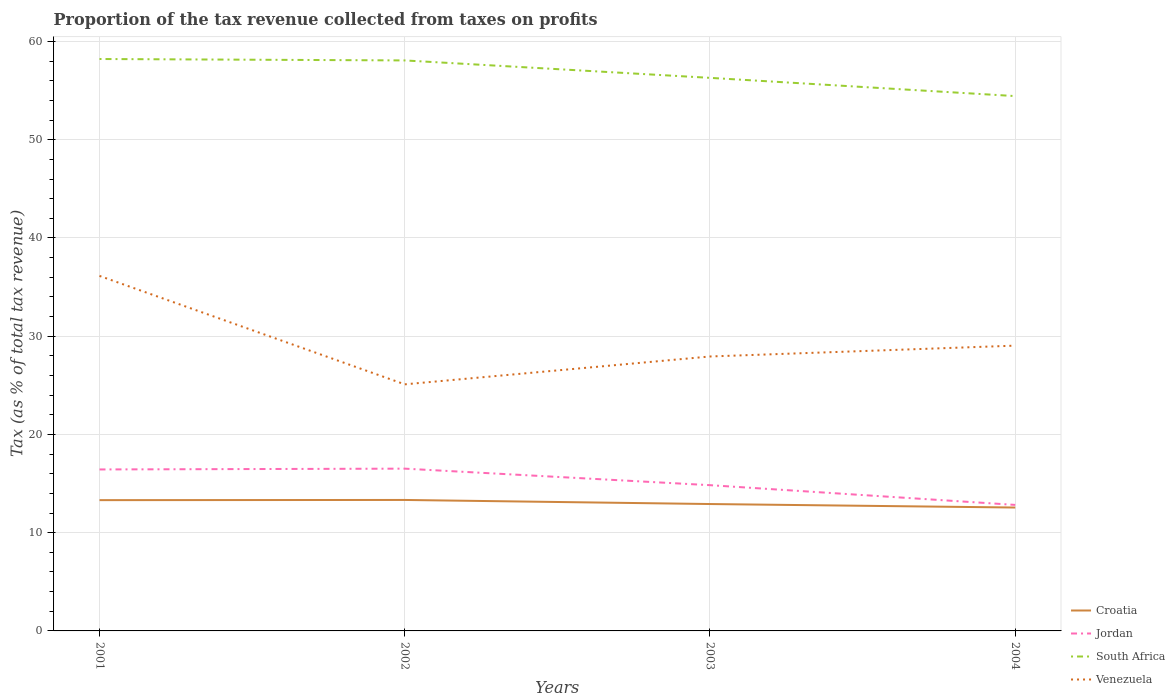How many different coloured lines are there?
Ensure brevity in your answer.  4. Across all years, what is the maximum proportion of the tax revenue collected in Venezuela?
Keep it short and to the point. 25.1. What is the total proportion of the tax revenue collected in Jordan in the graph?
Your response must be concise. -0.08. What is the difference between the highest and the second highest proportion of the tax revenue collected in Croatia?
Provide a succinct answer. 0.77. What is the difference between the highest and the lowest proportion of the tax revenue collected in Croatia?
Make the answer very short. 2. How many lines are there?
Offer a very short reply. 4. What is the difference between two consecutive major ticks on the Y-axis?
Give a very brief answer. 10. Are the values on the major ticks of Y-axis written in scientific E-notation?
Offer a terse response. No. Does the graph contain grids?
Offer a terse response. Yes. Where does the legend appear in the graph?
Your answer should be compact. Bottom right. How many legend labels are there?
Make the answer very short. 4. What is the title of the graph?
Offer a very short reply. Proportion of the tax revenue collected from taxes on profits. Does "Russian Federation" appear as one of the legend labels in the graph?
Keep it short and to the point. No. What is the label or title of the Y-axis?
Provide a short and direct response. Tax (as % of total tax revenue). What is the Tax (as % of total tax revenue) of Croatia in 2001?
Offer a terse response. 13.31. What is the Tax (as % of total tax revenue) in Jordan in 2001?
Keep it short and to the point. 16.44. What is the Tax (as % of total tax revenue) in South Africa in 2001?
Make the answer very short. 58.22. What is the Tax (as % of total tax revenue) in Venezuela in 2001?
Offer a terse response. 36.14. What is the Tax (as % of total tax revenue) of Croatia in 2002?
Offer a terse response. 13.33. What is the Tax (as % of total tax revenue) in Jordan in 2002?
Offer a terse response. 16.52. What is the Tax (as % of total tax revenue) of South Africa in 2002?
Make the answer very short. 58.08. What is the Tax (as % of total tax revenue) of Venezuela in 2002?
Give a very brief answer. 25.1. What is the Tax (as % of total tax revenue) of Croatia in 2003?
Keep it short and to the point. 12.92. What is the Tax (as % of total tax revenue) of Jordan in 2003?
Give a very brief answer. 14.84. What is the Tax (as % of total tax revenue) in South Africa in 2003?
Provide a succinct answer. 56.3. What is the Tax (as % of total tax revenue) in Venezuela in 2003?
Your answer should be very brief. 27.94. What is the Tax (as % of total tax revenue) of Croatia in 2004?
Offer a very short reply. 12.56. What is the Tax (as % of total tax revenue) in Jordan in 2004?
Provide a succinct answer. 12.83. What is the Tax (as % of total tax revenue) in South Africa in 2004?
Give a very brief answer. 54.45. What is the Tax (as % of total tax revenue) of Venezuela in 2004?
Offer a terse response. 29.04. Across all years, what is the maximum Tax (as % of total tax revenue) in Croatia?
Offer a very short reply. 13.33. Across all years, what is the maximum Tax (as % of total tax revenue) in Jordan?
Your response must be concise. 16.52. Across all years, what is the maximum Tax (as % of total tax revenue) in South Africa?
Provide a succinct answer. 58.22. Across all years, what is the maximum Tax (as % of total tax revenue) of Venezuela?
Keep it short and to the point. 36.14. Across all years, what is the minimum Tax (as % of total tax revenue) in Croatia?
Offer a very short reply. 12.56. Across all years, what is the minimum Tax (as % of total tax revenue) of Jordan?
Keep it short and to the point. 12.83. Across all years, what is the minimum Tax (as % of total tax revenue) of South Africa?
Your answer should be compact. 54.45. Across all years, what is the minimum Tax (as % of total tax revenue) in Venezuela?
Ensure brevity in your answer.  25.1. What is the total Tax (as % of total tax revenue) in Croatia in the graph?
Provide a short and direct response. 52.12. What is the total Tax (as % of total tax revenue) of Jordan in the graph?
Keep it short and to the point. 60.62. What is the total Tax (as % of total tax revenue) of South Africa in the graph?
Make the answer very short. 227.05. What is the total Tax (as % of total tax revenue) in Venezuela in the graph?
Ensure brevity in your answer.  118.23. What is the difference between the Tax (as % of total tax revenue) in Croatia in 2001 and that in 2002?
Keep it short and to the point. -0.02. What is the difference between the Tax (as % of total tax revenue) in Jordan in 2001 and that in 2002?
Provide a short and direct response. -0.08. What is the difference between the Tax (as % of total tax revenue) of South Africa in 2001 and that in 2002?
Your answer should be very brief. 0.15. What is the difference between the Tax (as % of total tax revenue) of Venezuela in 2001 and that in 2002?
Keep it short and to the point. 11.04. What is the difference between the Tax (as % of total tax revenue) of Croatia in 2001 and that in 2003?
Give a very brief answer. 0.4. What is the difference between the Tax (as % of total tax revenue) in Jordan in 2001 and that in 2003?
Provide a succinct answer. 1.6. What is the difference between the Tax (as % of total tax revenue) of South Africa in 2001 and that in 2003?
Provide a succinct answer. 1.92. What is the difference between the Tax (as % of total tax revenue) in Venezuela in 2001 and that in 2003?
Offer a very short reply. 8.2. What is the difference between the Tax (as % of total tax revenue) of Croatia in 2001 and that in 2004?
Provide a succinct answer. 0.75. What is the difference between the Tax (as % of total tax revenue) in Jordan in 2001 and that in 2004?
Provide a short and direct response. 3.61. What is the difference between the Tax (as % of total tax revenue) of South Africa in 2001 and that in 2004?
Provide a short and direct response. 3.78. What is the difference between the Tax (as % of total tax revenue) in Venezuela in 2001 and that in 2004?
Keep it short and to the point. 7.1. What is the difference between the Tax (as % of total tax revenue) in Croatia in 2002 and that in 2003?
Offer a terse response. 0.41. What is the difference between the Tax (as % of total tax revenue) in Jordan in 2002 and that in 2003?
Make the answer very short. 1.68. What is the difference between the Tax (as % of total tax revenue) of South Africa in 2002 and that in 2003?
Offer a very short reply. 1.77. What is the difference between the Tax (as % of total tax revenue) of Venezuela in 2002 and that in 2003?
Your answer should be very brief. -2.84. What is the difference between the Tax (as % of total tax revenue) of Croatia in 2002 and that in 2004?
Give a very brief answer. 0.77. What is the difference between the Tax (as % of total tax revenue) of Jordan in 2002 and that in 2004?
Your answer should be very brief. 3.69. What is the difference between the Tax (as % of total tax revenue) in South Africa in 2002 and that in 2004?
Your response must be concise. 3.63. What is the difference between the Tax (as % of total tax revenue) of Venezuela in 2002 and that in 2004?
Make the answer very short. -3.94. What is the difference between the Tax (as % of total tax revenue) in Croatia in 2003 and that in 2004?
Keep it short and to the point. 0.36. What is the difference between the Tax (as % of total tax revenue) of Jordan in 2003 and that in 2004?
Give a very brief answer. 2.01. What is the difference between the Tax (as % of total tax revenue) in South Africa in 2003 and that in 2004?
Ensure brevity in your answer.  1.86. What is the difference between the Tax (as % of total tax revenue) of Venezuela in 2003 and that in 2004?
Offer a very short reply. -1.1. What is the difference between the Tax (as % of total tax revenue) of Croatia in 2001 and the Tax (as % of total tax revenue) of Jordan in 2002?
Your response must be concise. -3.21. What is the difference between the Tax (as % of total tax revenue) of Croatia in 2001 and the Tax (as % of total tax revenue) of South Africa in 2002?
Give a very brief answer. -44.76. What is the difference between the Tax (as % of total tax revenue) in Croatia in 2001 and the Tax (as % of total tax revenue) in Venezuela in 2002?
Offer a very short reply. -11.79. What is the difference between the Tax (as % of total tax revenue) in Jordan in 2001 and the Tax (as % of total tax revenue) in South Africa in 2002?
Your answer should be compact. -41.64. What is the difference between the Tax (as % of total tax revenue) in Jordan in 2001 and the Tax (as % of total tax revenue) in Venezuela in 2002?
Offer a very short reply. -8.66. What is the difference between the Tax (as % of total tax revenue) of South Africa in 2001 and the Tax (as % of total tax revenue) of Venezuela in 2002?
Provide a succinct answer. 33.12. What is the difference between the Tax (as % of total tax revenue) in Croatia in 2001 and the Tax (as % of total tax revenue) in Jordan in 2003?
Give a very brief answer. -1.52. What is the difference between the Tax (as % of total tax revenue) in Croatia in 2001 and the Tax (as % of total tax revenue) in South Africa in 2003?
Keep it short and to the point. -42.99. What is the difference between the Tax (as % of total tax revenue) in Croatia in 2001 and the Tax (as % of total tax revenue) in Venezuela in 2003?
Provide a succinct answer. -14.62. What is the difference between the Tax (as % of total tax revenue) of Jordan in 2001 and the Tax (as % of total tax revenue) of South Africa in 2003?
Provide a succinct answer. -39.87. What is the difference between the Tax (as % of total tax revenue) of Jordan in 2001 and the Tax (as % of total tax revenue) of Venezuela in 2003?
Provide a short and direct response. -11.5. What is the difference between the Tax (as % of total tax revenue) of South Africa in 2001 and the Tax (as % of total tax revenue) of Venezuela in 2003?
Offer a terse response. 30.28. What is the difference between the Tax (as % of total tax revenue) in Croatia in 2001 and the Tax (as % of total tax revenue) in Jordan in 2004?
Ensure brevity in your answer.  0.49. What is the difference between the Tax (as % of total tax revenue) in Croatia in 2001 and the Tax (as % of total tax revenue) in South Africa in 2004?
Provide a succinct answer. -41.13. What is the difference between the Tax (as % of total tax revenue) in Croatia in 2001 and the Tax (as % of total tax revenue) in Venezuela in 2004?
Offer a terse response. -15.73. What is the difference between the Tax (as % of total tax revenue) in Jordan in 2001 and the Tax (as % of total tax revenue) in South Africa in 2004?
Your answer should be very brief. -38.01. What is the difference between the Tax (as % of total tax revenue) in Jordan in 2001 and the Tax (as % of total tax revenue) in Venezuela in 2004?
Offer a very short reply. -12.61. What is the difference between the Tax (as % of total tax revenue) in South Africa in 2001 and the Tax (as % of total tax revenue) in Venezuela in 2004?
Give a very brief answer. 29.18. What is the difference between the Tax (as % of total tax revenue) of Croatia in 2002 and the Tax (as % of total tax revenue) of Jordan in 2003?
Offer a terse response. -1.5. What is the difference between the Tax (as % of total tax revenue) in Croatia in 2002 and the Tax (as % of total tax revenue) in South Africa in 2003?
Provide a short and direct response. -42.97. What is the difference between the Tax (as % of total tax revenue) in Croatia in 2002 and the Tax (as % of total tax revenue) in Venezuela in 2003?
Keep it short and to the point. -14.61. What is the difference between the Tax (as % of total tax revenue) of Jordan in 2002 and the Tax (as % of total tax revenue) of South Africa in 2003?
Your response must be concise. -39.78. What is the difference between the Tax (as % of total tax revenue) in Jordan in 2002 and the Tax (as % of total tax revenue) in Venezuela in 2003?
Provide a short and direct response. -11.42. What is the difference between the Tax (as % of total tax revenue) in South Africa in 2002 and the Tax (as % of total tax revenue) in Venezuela in 2003?
Offer a very short reply. 30.14. What is the difference between the Tax (as % of total tax revenue) in Croatia in 2002 and the Tax (as % of total tax revenue) in Jordan in 2004?
Offer a very short reply. 0.5. What is the difference between the Tax (as % of total tax revenue) of Croatia in 2002 and the Tax (as % of total tax revenue) of South Africa in 2004?
Ensure brevity in your answer.  -41.11. What is the difference between the Tax (as % of total tax revenue) in Croatia in 2002 and the Tax (as % of total tax revenue) in Venezuela in 2004?
Provide a short and direct response. -15.71. What is the difference between the Tax (as % of total tax revenue) of Jordan in 2002 and the Tax (as % of total tax revenue) of South Africa in 2004?
Give a very brief answer. -37.93. What is the difference between the Tax (as % of total tax revenue) of Jordan in 2002 and the Tax (as % of total tax revenue) of Venezuela in 2004?
Your response must be concise. -12.52. What is the difference between the Tax (as % of total tax revenue) of South Africa in 2002 and the Tax (as % of total tax revenue) of Venezuela in 2004?
Offer a very short reply. 29.03. What is the difference between the Tax (as % of total tax revenue) of Croatia in 2003 and the Tax (as % of total tax revenue) of Jordan in 2004?
Make the answer very short. 0.09. What is the difference between the Tax (as % of total tax revenue) of Croatia in 2003 and the Tax (as % of total tax revenue) of South Africa in 2004?
Keep it short and to the point. -41.53. What is the difference between the Tax (as % of total tax revenue) in Croatia in 2003 and the Tax (as % of total tax revenue) in Venezuela in 2004?
Your answer should be compact. -16.13. What is the difference between the Tax (as % of total tax revenue) of Jordan in 2003 and the Tax (as % of total tax revenue) of South Africa in 2004?
Make the answer very short. -39.61. What is the difference between the Tax (as % of total tax revenue) of Jordan in 2003 and the Tax (as % of total tax revenue) of Venezuela in 2004?
Give a very brief answer. -14.21. What is the difference between the Tax (as % of total tax revenue) in South Africa in 2003 and the Tax (as % of total tax revenue) in Venezuela in 2004?
Your answer should be very brief. 27.26. What is the average Tax (as % of total tax revenue) in Croatia per year?
Your response must be concise. 13.03. What is the average Tax (as % of total tax revenue) in Jordan per year?
Offer a terse response. 15.16. What is the average Tax (as % of total tax revenue) in South Africa per year?
Offer a terse response. 56.76. What is the average Tax (as % of total tax revenue) in Venezuela per year?
Give a very brief answer. 29.56. In the year 2001, what is the difference between the Tax (as % of total tax revenue) in Croatia and Tax (as % of total tax revenue) in Jordan?
Your answer should be very brief. -3.12. In the year 2001, what is the difference between the Tax (as % of total tax revenue) of Croatia and Tax (as % of total tax revenue) of South Africa?
Your response must be concise. -44.91. In the year 2001, what is the difference between the Tax (as % of total tax revenue) in Croatia and Tax (as % of total tax revenue) in Venezuela?
Make the answer very short. -22.83. In the year 2001, what is the difference between the Tax (as % of total tax revenue) of Jordan and Tax (as % of total tax revenue) of South Africa?
Offer a very short reply. -41.78. In the year 2001, what is the difference between the Tax (as % of total tax revenue) of Jordan and Tax (as % of total tax revenue) of Venezuela?
Your answer should be compact. -19.7. In the year 2001, what is the difference between the Tax (as % of total tax revenue) in South Africa and Tax (as % of total tax revenue) in Venezuela?
Your answer should be very brief. 22.08. In the year 2002, what is the difference between the Tax (as % of total tax revenue) of Croatia and Tax (as % of total tax revenue) of Jordan?
Offer a terse response. -3.19. In the year 2002, what is the difference between the Tax (as % of total tax revenue) of Croatia and Tax (as % of total tax revenue) of South Africa?
Keep it short and to the point. -44.74. In the year 2002, what is the difference between the Tax (as % of total tax revenue) of Croatia and Tax (as % of total tax revenue) of Venezuela?
Your answer should be compact. -11.77. In the year 2002, what is the difference between the Tax (as % of total tax revenue) of Jordan and Tax (as % of total tax revenue) of South Africa?
Give a very brief answer. -41.56. In the year 2002, what is the difference between the Tax (as % of total tax revenue) in Jordan and Tax (as % of total tax revenue) in Venezuela?
Keep it short and to the point. -8.58. In the year 2002, what is the difference between the Tax (as % of total tax revenue) of South Africa and Tax (as % of total tax revenue) of Venezuela?
Your answer should be very brief. 32.97. In the year 2003, what is the difference between the Tax (as % of total tax revenue) in Croatia and Tax (as % of total tax revenue) in Jordan?
Offer a very short reply. -1.92. In the year 2003, what is the difference between the Tax (as % of total tax revenue) in Croatia and Tax (as % of total tax revenue) in South Africa?
Ensure brevity in your answer.  -43.39. In the year 2003, what is the difference between the Tax (as % of total tax revenue) of Croatia and Tax (as % of total tax revenue) of Venezuela?
Your answer should be very brief. -15.02. In the year 2003, what is the difference between the Tax (as % of total tax revenue) in Jordan and Tax (as % of total tax revenue) in South Africa?
Make the answer very short. -41.47. In the year 2003, what is the difference between the Tax (as % of total tax revenue) of Jordan and Tax (as % of total tax revenue) of Venezuela?
Your answer should be very brief. -13.1. In the year 2003, what is the difference between the Tax (as % of total tax revenue) in South Africa and Tax (as % of total tax revenue) in Venezuela?
Make the answer very short. 28.36. In the year 2004, what is the difference between the Tax (as % of total tax revenue) of Croatia and Tax (as % of total tax revenue) of Jordan?
Offer a very short reply. -0.27. In the year 2004, what is the difference between the Tax (as % of total tax revenue) of Croatia and Tax (as % of total tax revenue) of South Africa?
Provide a short and direct response. -41.88. In the year 2004, what is the difference between the Tax (as % of total tax revenue) of Croatia and Tax (as % of total tax revenue) of Venezuela?
Your answer should be compact. -16.48. In the year 2004, what is the difference between the Tax (as % of total tax revenue) in Jordan and Tax (as % of total tax revenue) in South Africa?
Make the answer very short. -41.62. In the year 2004, what is the difference between the Tax (as % of total tax revenue) of Jordan and Tax (as % of total tax revenue) of Venezuela?
Provide a succinct answer. -16.22. In the year 2004, what is the difference between the Tax (as % of total tax revenue) in South Africa and Tax (as % of total tax revenue) in Venezuela?
Your answer should be very brief. 25.4. What is the ratio of the Tax (as % of total tax revenue) of Croatia in 2001 to that in 2002?
Your response must be concise. 1. What is the ratio of the Tax (as % of total tax revenue) of South Africa in 2001 to that in 2002?
Provide a succinct answer. 1. What is the ratio of the Tax (as % of total tax revenue) in Venezuela in 2001 to that in 2002?
Provide a succinct answer. 1.44. What is the ratio of the Tax (as % of total tax revenue) of Croatia in 2001 to that in 2003?
Give a very brief answer. 1.03. What is the ratio of the Tax (as % of total tax revenue) in Jordan in 2001 to that in 2003?
Ensure brevity in your answer.  1.11. What is the ratio of the Tax (as % of total tax revenue) of South Africa in 2001 to that in 2003?
Your answer should be compact. 1.03. What is the ratio of the Tax (as % of total tax revenue) of Venezuela in 2001 to that in 2003?
Keep it short and to the point. 1.29. What is the ratio of the Tax (as % of total tax revenue) of Croatia in 2001 to that in 2004?
Give a very brief answer. 1.06. What is the ratio of the Tax (as % of total tax revenue) in Jordan in 2001 to that in 2004?
Offer a very short reply. 1.28. What is the ratio of the Tax (as % of total tax revenue) in South Africa in 2001 to that in 2004?
Offer a terse response. 1.07. What is the ratio of the Tax (as % of total tax revenue) of Venezuela in 2001 to that in 2004?
Keep it short and to the point. 1.24. What is the ratio of the Tax (as % of total tax revenue) in Croatia in 2002 to that in 2003?
Provide a short and direct response. 1.03. What is the ratio of the Tax (as % of total tax revenue) of Jordan in 2002 to that in 2003?
Provide a succinct answer. 1.11. What is the ratio of the Tax (as % of total tax revenue) of South Africa in 2002 to that in 2003?
Offer a very short reply. 1.03. What is the ratio of the Tax (as % of total tax revenue) of Venezuela in 2002 to that in 2003?
Make the answer very short. 0.9. What is the ratio of the Tax (as % of total tax revenue) in Croatia in 2002 to that in 2004?
Your response must be concise. 1.06. What is the ratio of the Tax (as % of total tax revenue) in Jordan in 2002 to that in 2004?
Make the answer very short. 1.29. What is the ratio of the Tax (as % of total tax revenue) of South Africa in 2002 to that in 2004?
Offer a very short reply. 1.07. What is the ratio of the Tax (as % of total tax revenue) in Venezuela in 2002 to that in 2004?
Make the answer very short. 0.86. What is the ratio of the Tax (as % of total tax revenue) in Croatia in 2003 to that in 2004?
Give a very brief answer. 1.03. What is the ratio of the Tax (as % of total tax revenue) in Jordan in 2003 to that in 2004?
Give a very brief answer. 1.16. What is the ratio of the Tax (as % of total tax revenue) of South Africa in 2003 to that in 2004?
Your answer should be compact. 1.03. What is the ratio of the Tax (as % of total tax revenue) of Venezuela in 2003 to that in 2004?
Provide a succinct answer. 0.96. What is the difference between the highest and the second highest Tax (as % of total tax revenue) in Croatia?
Offer a terse response. 0.02. What is the difference between the highest and the second highest Tax (as % of total tax revenue) of Jordan?
Provide a short and direct response. 0.08. What is the difference between the highest and the second highest Tax (as % of total tax revenue) in South Africa?
Your answer should be compact. 0.15. What is the difference between the highest and the second highest Tax (as % of total tax revenue) in Venezuela?
Offer a terse response. 7.1. What is the difference between the highest and the lowest Tax (as % of total tax revenue) in Croatia?
Ensure brevity in your answer.  0.77. What is the difference between the highest and the lowest Tax (as % of total tax revenue) of Jordan?
Your answer should be very brief. 3.69. What is the difference between the highest and the lowest Tax (as % of total tax revenue) of South Africa?
Your answer should be compact. 3.78. What is the difference between the highest and the lowest Tax (as % of total tax revenue) in Venezuela?
Offer a very short reply. 11.04. 